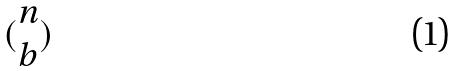Convert formula to latex. <formula><loc_0><loc_0><loc_500><loc_500>( \begin{matrix} n \\ b \end{matrix} )</formula> 